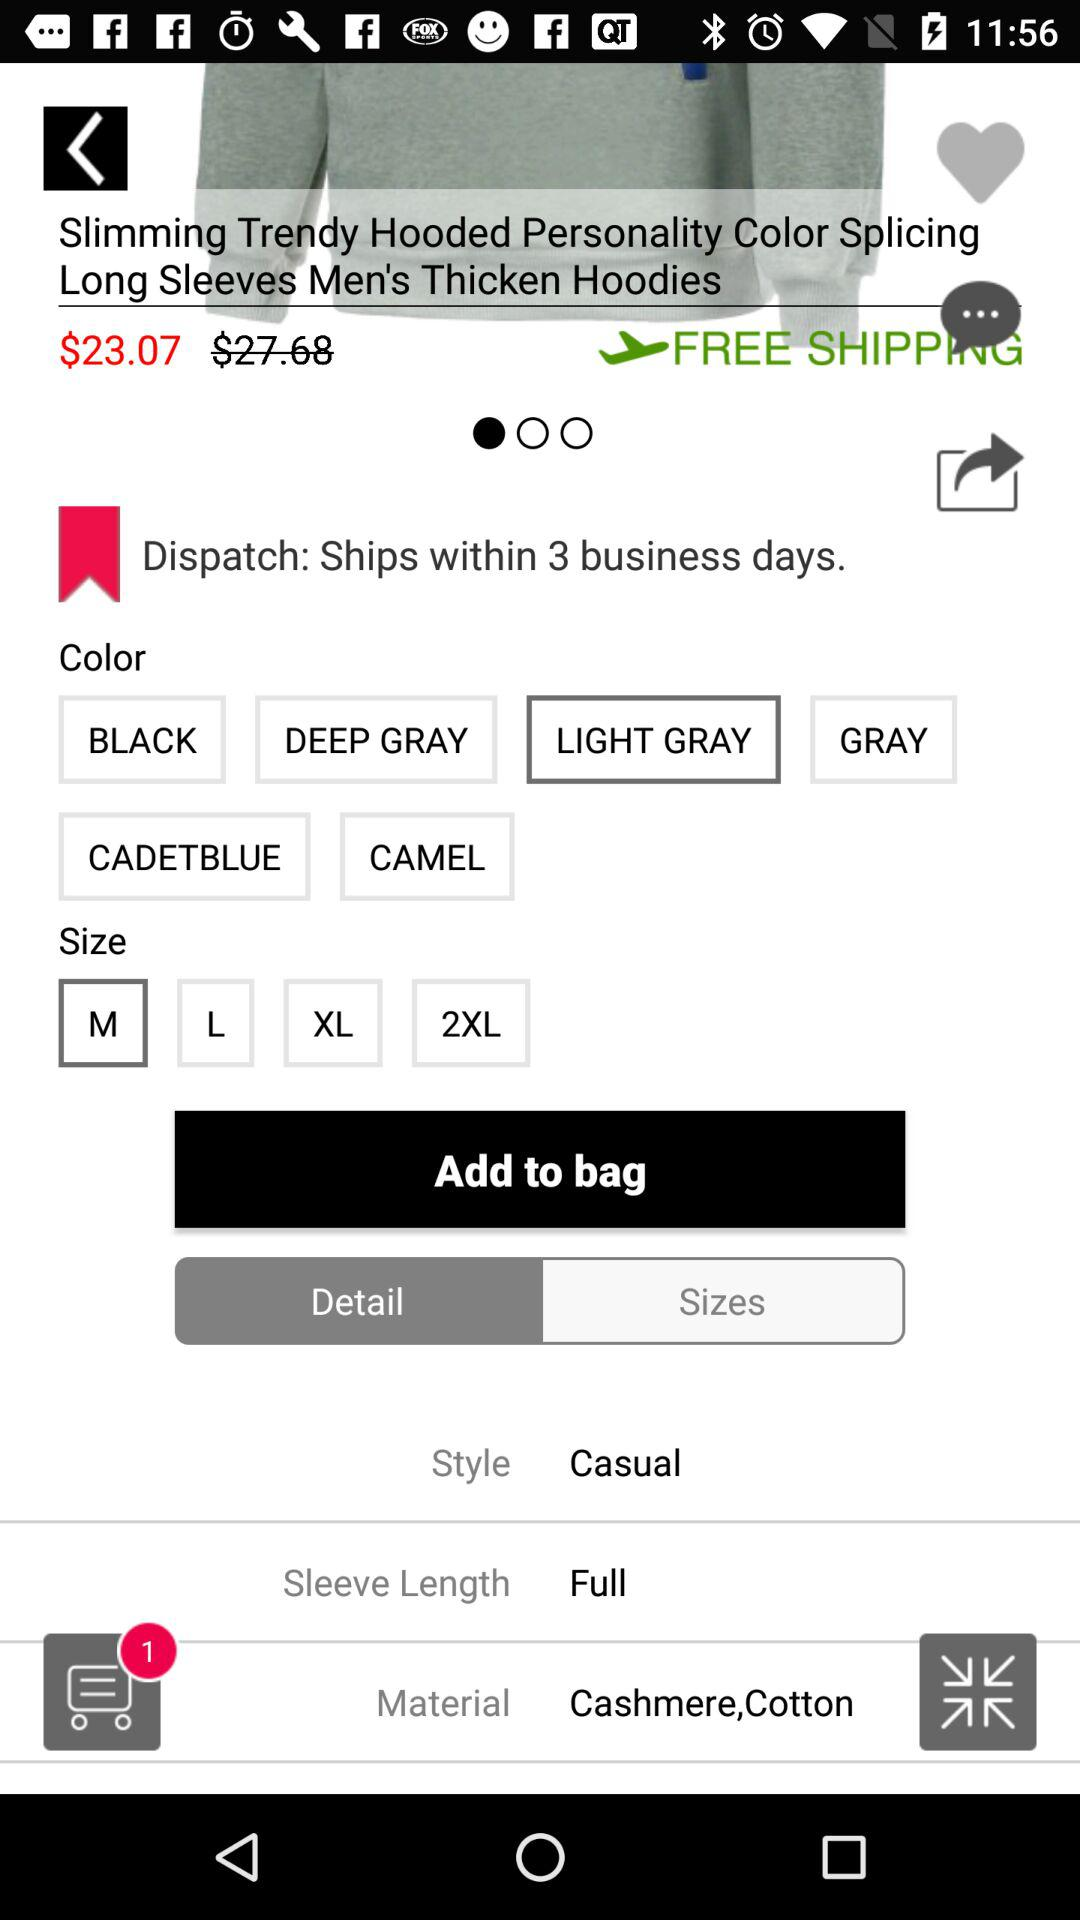Within how many business days can the shipping be done? The shipping can be done within 3 business days. 